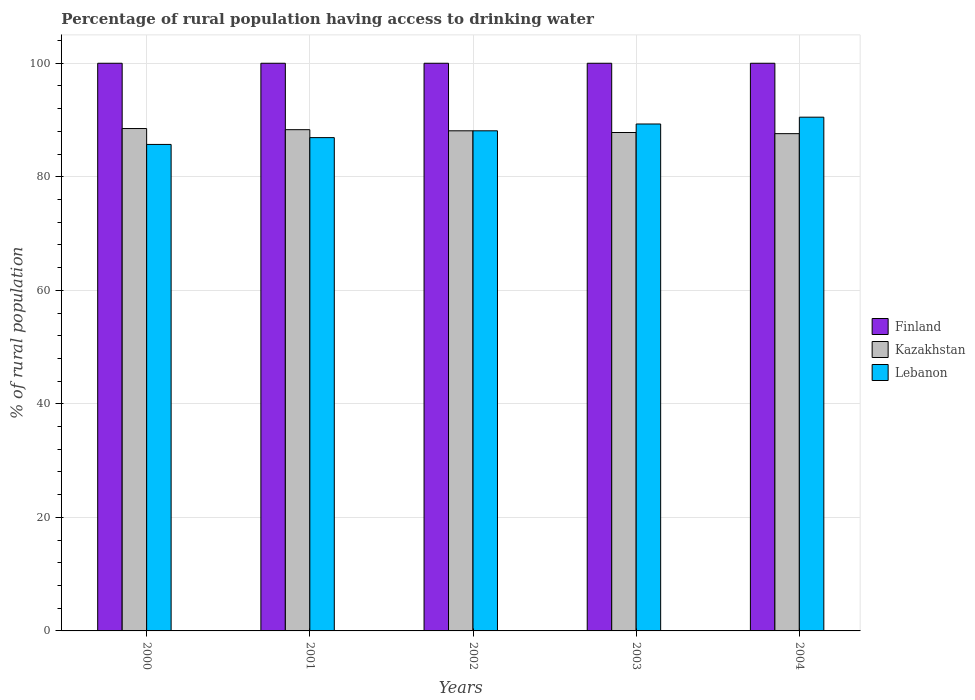How many different coloured bars are there?
Your answer should be compact. 3. How many groups of bars are there?
Ensure brevity in your answer.  5. What is the label of the 3rd group of bars from the left?
Ensure brevity in your answer.  2002. In how many cases, is the number of bars for a given year not equal to the number of legend labels?
Make the answer very short. 0. What is the percentage of rural population having access to drinking water in Lebanon in 2000?
Your answer should be very brief. 85.7. Across all years, what is the maximum percentage of rural population having access to drinking water in Finland?
Offer a very short reply. 100. Across all years, what is the minimum percentage of rural population having access to drinking water in Lebanon?
Ensure brevity in your answer.  85.7. In which year was the percentage of rural population having access to drinking water in Finland maximum?
Make the answer very short. 2000. What is the total percentage of rural population having access to drinking water in Kazakhstan in the graph?
Your response must be concise. 440.3. What is the difference between the percentage of rural population having access to drinking water in Kazakhstan in 2002 and that in 2003?
Your response must be concise. 0.3. What is the difference between the percentage of rural population having access to drinking water in Kazakhstan in 2003 and the percentage of rural population having access to drinking water in Finland in 2001?
Give a very brief answer. -12.2. What is the average percentage of rural population having access to drinking water in Kazakhstan per year?
Offer a terse response. 88.06. In the year 2004, what is the difference between the percentage of rural population having access to drinking water in Lebanon and percentage of rural population having access to drinking water in Kazakhstan?
Ensure brevity in your answer.  2.9. What is the ratio of the percentage of rural population having access to drinking water in Lebanon in 2000 to that in 2004?
Your answer should be compact. 0.95. Is the percentage of rural population having access to drinking water in Kazakhstan in 2000 less than that in 2003?
Your answer should be very brief. No. What is the difference between the highest and the lowest percentage of rural population having access to drinking water in Lebanon?
Offer a very short reply. 4.8. What does the 1st bar from the left in 2000 represents?
Provide a short and direct response. Finland. What does the 3rd bar from the right in 2004 represents?
Provide a succinct answer. Finland. Is it the case that in every year, the sum of the percentage of rural population having access to drinking water in Kazakhstan and percentage of rural population having access to drinking water in Finland is greater than the percentage of rural population having access to drinking water in Lebanon?
Offer a very short reply. Yes. Are all the bars in the graph horizontal?
Provide a short and direct response. No. Are the values on the major ticks of Y-axis written in scientific E-notation?
Your answer should be compact. No. Does the graph contain any zero values?
Ensure brevity in your answer.  No. Where does the legend appear in the graph?
Provide a short and direct response. Center right. How many legend labels are there?
Offer a very short reply. 3. How are the legend labels stacked?
Your response must be concise. Vertical. What is the title of the graph?
Offer a very short reply. Percentage of rural population having access to drinking water. What is the label or title of the X-axis?
Your answer should be very brief. Years. What is the label or title of the Y-axis?
Provide a succinct answer. % of rural population. What is the % of rural population in Kazakhstan in 2000?
Your answer should be very brief. 88.5. What is the % of rural population in Lebanon in 2000?
Offer a very short reply. 85.7. What is the % of rural population in Finland in 2001?
Offer a very short reply. 100. What is the % of rural population of Kazakhstan in 2001?
Ensure brevity in your answer.  88.3. What is the % of rural population in Lebanon in 2001?
Offer a very short reply. 86.9. What is the % of rural population in Kazakhstan in 2002?
Offer a terse response. 88.1. What is the % of rural population in Lebanon in 2002?
Ensure brevity in your answer.  88.1. What is the % of rural population in Finland in 2003?
Your answer should be very brief. 100. What is the % of rural population in Kazakhstan in 2003?
Ensure brevity in your answer.  87.8. What is the % of rural population of Lebanon in 2003?
Provide a short and direct response. 89.3. What is the % of rural population in Finland in 2004?
Provide a short and direct response. 100. What is the % of rural population in Kazakhstan in 2004?
Offer a terse response. 87.6. What is the % of rural population in Lebanon in 2004?
Keep it short and to the point. 90.5. Across all years, what is the maximum % of rural population of Finland?
Make the answer very short. 100. Across all years, what is the maximum % of rural population in Kazakhstan?
Keep it short and to the point. 88.5. Across all years, what is the maximum % of rural population in Lebanon?
Provide a short and direct response. 90.5. Across all years, what is the minimum % of rural population in Finland?
Keep it short and to the point. 100. Across all years, what is the minimum % of rural population of Kazakhstan?
Ensure brevity in your answer.  87.6. Across all years, what is the minimum % of rural population in Lebanon?
Offer a terse response. 85.7. What is the total % of rural population in Kazakhstan in the graph?
Keep it short and to the point. 440.3. What is the total % of rural population of Lebanon in the graph?
Provide a succinct answer. 440.5. What is the difference between the % of rural population in Kazakhstan in 2000 and that in 2001?
Keep it short and to the point. 0.2. What is the difference between the % of rural population of Lebanon in 2000 and that in 2001?
Ensure brevity in your answer.  -1.2. What is the difference between the % of rural population of Finland in 2000 and that in 2002?
Give a very brief answer. 0. What is the difference between the % of rural population in Lebanon in 2000 and that in 2002?
Ensure brevity in your answer.  -2.4. What is the difference between the % of rural population in Kazakhstan in 2000 and that in 2003?
Provide a short and direct response. 0.7. What is the difference between the % of rural population of Lebanon in 2000 and that in 2003?
Your answer should be compact. -3.6. What is the difference between the % of rural population in Finland in 2001 and that in 2002?
Your response must be concise. 0. What is the difference between the % of rural population in Finland in 2001 and that in 2003?
Provide a short and direct response. 0. What is the difference between the % of rural population in Finland in 2001 and that in 2004?
Your response must be concise. 0. What is the difference between the % of rural population in Kazakhstan in 2001 and that in 2004?
Offer a terse response. 0.7. What is the difference between the % of rural population in Kazakhstan in 2002 and that in 2003?
Your response must be concise. 0.3. What is the difference between the % of rural population in Lebanon in 2002 and that in 2003?
Provide a short and direct response. -1.2. What is the difference between the % of rural population of Finland in 2002 and that in 2004?
Your response must be concise. 0. What is the difference between the % of rural population of Lebanon in 2002 and that in 2004?
Offer a terse response. -2.4. What is the difference between the % of rural population in Kazakhstan in 2003 and that in 2004?
Make the answer very short. 0.2. What is the difference between the % of rural population in Finland in 2000 and the % of rural population in Lebanon in 2001?
Ensure brevity in your answer.  13.1. What is the difference between the % of rural population of Kazakhstan in 2000 and the % of rural population of Lebanon in 2001?
Your answer should be very brief. 1.6. What is the difference between the % of rural population of Kazakhstan in 2000 and the % of rural population of Lebanon in 2003?
Offer a terse response. -0.8. What is the difference between the % of rural population of Kazakhstan in 2001 and the % of rural population of Lebanon in 2002?
Give a very brief answer. 0.2. What is the difference between the % of rural population of Finland in 2001 and the % of rural population of Kazakhstan in 2003?
Your answer should be very brief. 12.2. What is the difference between the % of rural population in Kazakhstan in 2001 and the % of rural population in Lebanon in 2003?
Offer a terse response. -1. What is the difference between the % of rural population in Finland in 2001 and the % of rural population in Lebanon in 2004?
Provide a short and direct response. 9.5. What is the difference between the % of rural population in Kazakhstan in 2002 and the % of rural population in Lebanon in 2003?
Provide a succinct answer. -1.2. What is the difference between the % of rural population of Kazakhstan in 2002 and the % of rural population of Lebanon in 2004?
Offer a very short reply. -2.4. What is the difference between the % of rural population of Finland in 2003 and the % of rural population of Kazakhstan in 2004?
Offer a terse response. 12.4. What is the difference between the % of rural population of Kazakhstan in 2003 and the % of rural population of Lebanon in 2004?
Offer a very short reply. -2.7. What is the average % of rural population in Finland per year?
Make the answer very short. 100. What is the average % of rural population in Kazakhstan per year?
Offer a very short reply. 88.06. What is the average % of rural population in Lebanon per year?
Your answer should be compact. 88.1. In the year 2000, what is the difference between the % of rural population of Finland and % of rural population of Kazakhstan?
Make the answer very short. 11.5. In the year 2001, what is the difference between the % of rural population in Finland and % of rural population in Lebanon?
Keep it short and to the point. 13.1. In the year 2002, what is the difference between the % of rural population of Finland and % of rural population of Kazakhstan?
Your answer should be compact. 11.9. In the year 2003, what is the difference between the % of rural population of Finland and % of rural population of Kazakhstan?
Keep it short and to the point. 12.2. In the year 2003, what is the difference between the % of rural population in Finland and % of rural population in Lebanon?
Your answer should be compact. 10.7. In the year 2003, what is the difference between the % of rural population in Kazakhstan and % of rural population in Lebanon?
Give a very brief answer. -1.5. In the year 2004, what is the difference between the % of rural population of Finland and % of rural population of Kazakhstan?
Offer a terse response. 12.4. In the year 2004, what is the difference between the % of rural population of Finland and % of rural population of Lebanon?
Your answer should be very brief. 9.5. In the year 2004, what is the difference between the % of rural population in Kazakhstan and % of rural population in Lebanon?
Ensure brevity in your answer.  -2.9. What is the ratio of the % of rural population in Lebanon in 2000 to that in 2001?
Your response must be concise. 0.99. What is the ratio of the % of rural population in Finland in 2000 to that in 2002?
Offer a terse response. 1. What is the ratio of the % of rural population of Kazakhstan in 2000 to that in 2002?
Make the answer very short. 1. What is the ratio of the % of rural population of Lebanon in 2000 to that in 2002?
Offer a terse response. 0.97. What is the ratio of the % of rural population of Finland in 2000 to that in 2003?
Offer a terse response. 1. What is the ratio of the % of rural population of Lebanon in 2000 to that in 2003?
Ensure brevity in your answer.  0.96. What is the ratio of the % of rural population in Kazakhstan in 2000 to that in 2004?
Provide a succinct answer. 1.01. What is the ratio of the % of rural population in Lebanon in 2000 to that in 2004?
Your response must be concise. 0.95. What is the ratio of the % of rural population of Lebanon in 2001 to that in 2002?
Ensure brevity in your answer.  0.99. What is the ratio of the % of rural population in Kazakhstan in 2001 to that in 2003?
Your response must be concise. 1.01. What is the ratio of the % of rural population in Lebanon in 2001 to that in 2003?
Provide a succinct answer. 0.97. What is the ratio of the % of rural population in Finland in 2001 to that in 2004?
Make the answer very short. 1. What is the ratio of the % of rural population in Kazakhstan in 2001 to that in 2004?
Make the answer very short. 1.01. What is the ratio of the % of rural population of Lebanon in 2001 to that in 2004?
Provide a short and direct response. 0.96. What is the ratio of the % of rural population of Finland in 2002 to that in 2003?
Offer a very short reply. 1. What is the ratio of the % of rural population in Lebanon in 2002 to that in 2003?
Offer a very short reply. 0.99. What is the ratio of the % of rural population in Finland in 2002 to that in 2004?
Offer a very short reply. 1. What is the ratio of the % of rural population in Kazakhstan in 2002 to that in 2004?
Your response must be concise. 1.01. What is the ratio of the % of rural population of Lebanon in 2002 to that in 2004?
Offer a very short reply. 0.97. What is the ratio of the % of rural population of Kazakhstan in 2003 to that in 2004?
Provide a short and direct response. 1. What is the ratio of the % of rural population of Lebanon in 2003 to that in 2004?
Provide a succinct answer. 0.99. What is the difference between the highest and the second highest % of rural population in Finland?
Provide a short and direct response. 0. What is the difference between the highest and the lowest % of rural population in Kazakhstan?
Your answer should be compact. 0.9. What is the difference between the highest and the lowest % of rural population in Lebanon?
Your response must be concise. 4.8. 